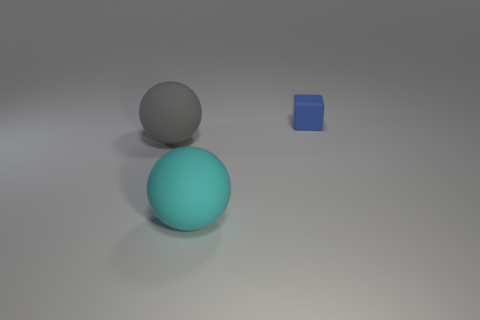The gray rubber object is what shape?
Give a very brief answer. Sphere. How many other big matte things have the same shape as the cyan matte object?
Give a very brief answer. 1. What number of objects are both in front of the blue rubber thing and right of the cyan ball?
Keep it short and to the point. 0. What is the color of the rubber cube?
Provide a succinct answer. Blue. Are there any small blue blocks made of the same material as the large cyan thing?
Offer a very short reply. Yes. Is there a tiny rubber block behind the rubber ball that is behind the object that is in front of the big gray sphere?
Your response must be concise. Yes. Are there any large rubber spheres in front of the big gray matte thing?
Offer a terse response. Yes. How many small things are either cyan spheres or red shiny balls?
Offer a very short reply. 0. Is the material of the large ball in front of the gray rubber ball the same as the tiny object?
Give a very brief answer. Yes. There is a big rubber object that is behind the large ball that is on the right side of the large rubber thing left of the cyan ball; what shape is it?
Ensure brevity in your answer.  Sphere. 